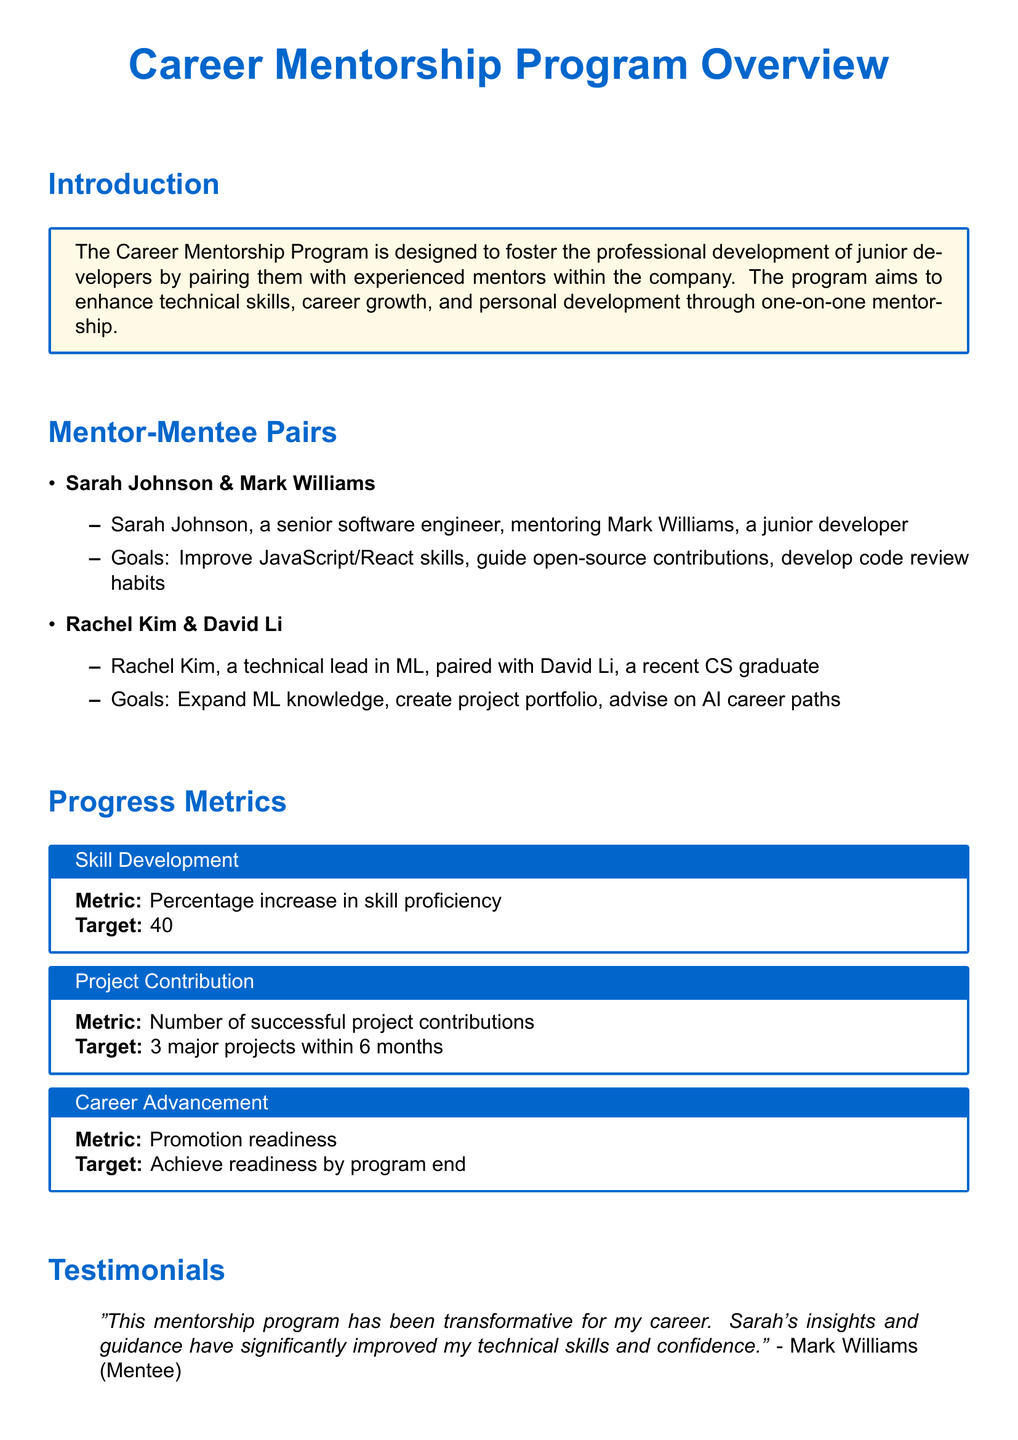What is the purpose of the Career Mentorship Program? The purpose is to foster the professional development of junior developers by pairing them with experienced mentors within the company.
Answer: Foster professional development Who is mentoring Mark Williams? Mark Williams is being mentored by Sarah Johnson, a senior software engineer.
Answer: Sarah Johnson What is the skill proficiency target improvement percentage? The target improvement percentage for skill proficiency is stated in the document.
Answer: 40% How many major projects should a mentee aim to contribute to within six months? The number of major projects is outlined in the progress metrics section of the document.
Answer: 3 What did Mark Williams say about the mentorship program? Mark Williams provided a testimonial stating how the program transformed his career.
Answer: Transformative Who is David Li's mentor? The document identifies Rachel Kim as David Li's mentor.
Answer: Rachel Kim What is the target for promotion readiness by the end of the program? The target for promotion readiness is a specific goal outlined in the metrics section.
Answer: Achieve readiness Which technical area did Rachel Kim help David Li expand? The technical area mentioned is machine learning, which Rachel Kim focuses on in her mentorship.
Answer: Machine learning 